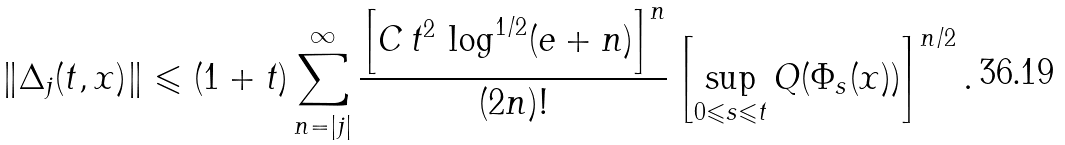Convert formula to latex. <formula><loc_0><loc_0><loc_500><loc_500>\left \| \Delta _ { j } ( t , x ) \right \| \leqslant ( 1 + t ) \sum _ { n = | j | } ^ { \infty } \frac { \left [ C \, t ^ { 2 } \, \log ^ { 1 / 2 } ( e + n ) \right ] ^ { n } } { ( 2 n ) ! } \left [ \sup _ { 0 \leqslant s \leqslant t } Q ( \Phi _ { s } ( x ) ) \right ] ^ { n / 2 } .</formula> 